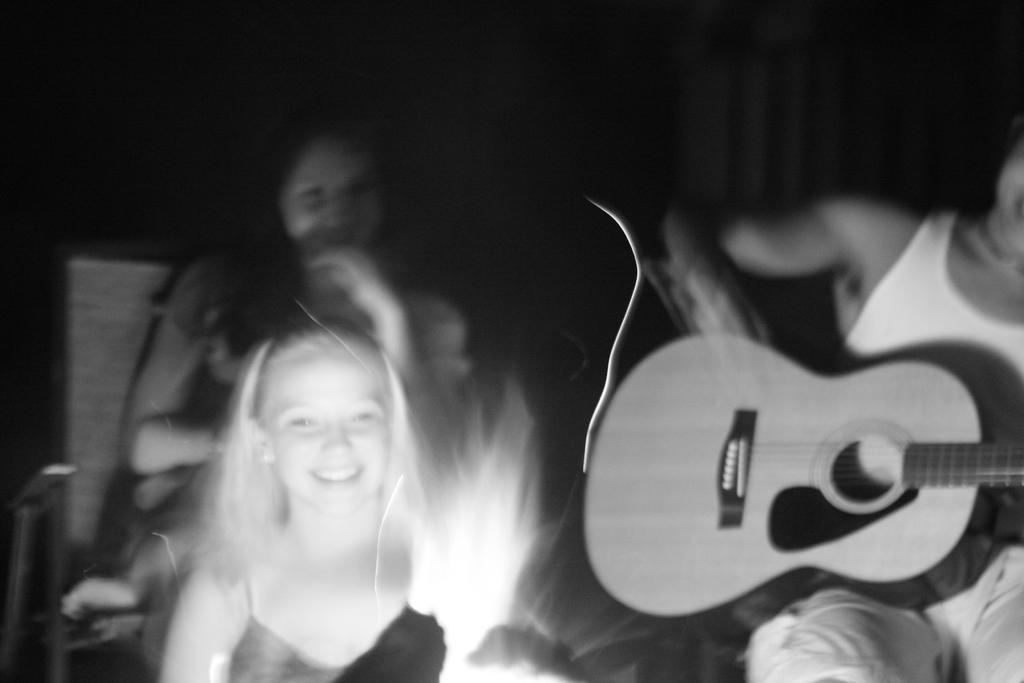What are the people in the image doing? The persons in the image are sitting. Can you describe the person sitting on a chair? The person sitting on a chair is holding a guitar. What is the color of the background in the image? The background of the image is dark. What type of bait is the person holding in the image? There is no bait present in the image; the person is holding a guitar. How many visitors can be seen in the image? There is no mention of visitors in the image; it only shows persons sitting. 